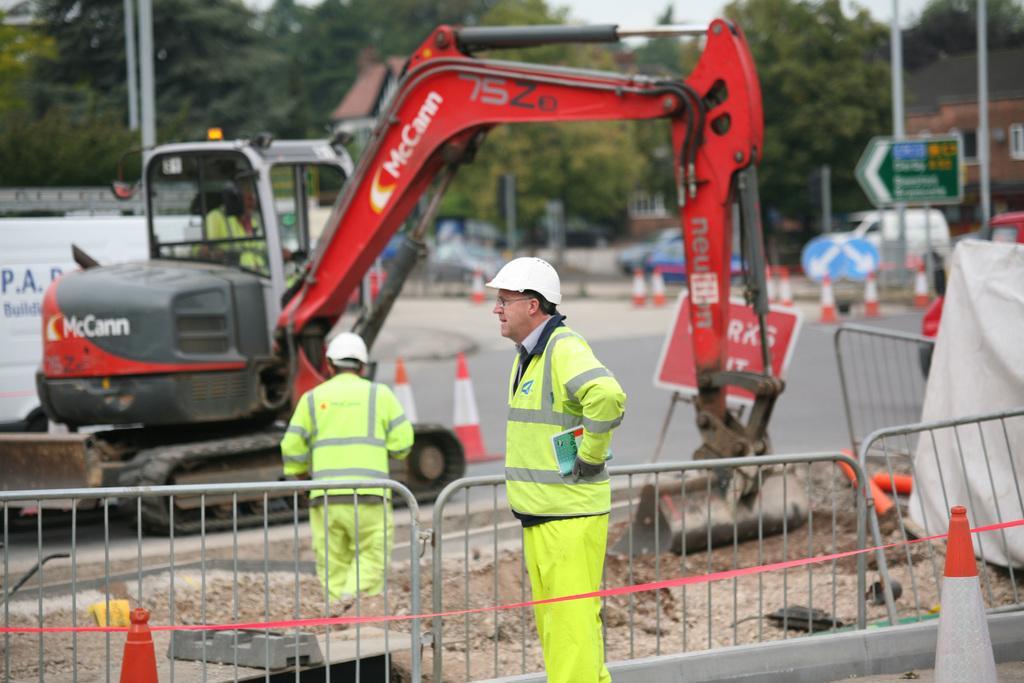Please provide a concise description of this image. In this picture we can see two people, fences, traffic cones, soil, direction boards and an excavator on the road. In the background we can see poles, trees, vehicles, buildings with windows, some objects and the sky. 